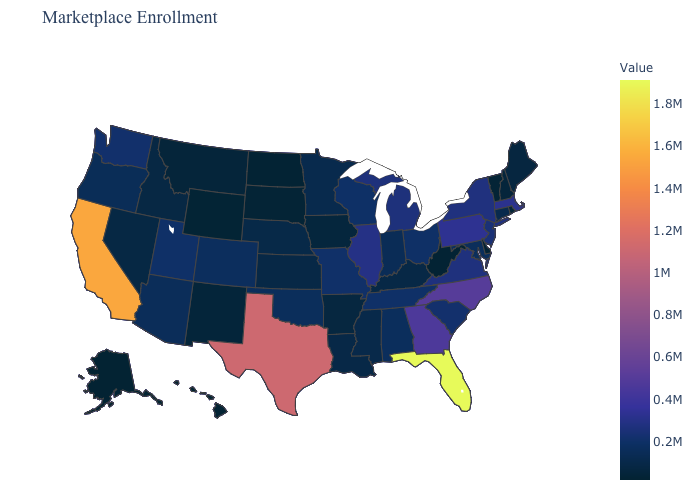Which states have the lowest value in the USA?
Short answer required. Alaska. Which states have the lowest value in the Northeast?
Be succinct. Vermont. Does Kentucky have the lowest value in the USA?
Keep it brief. No. Which states have the lowest value in the Northeast?
Give a very brief answer. Vermont. Which states have the lowest value in the USA?
Be succinct. Alaska. 